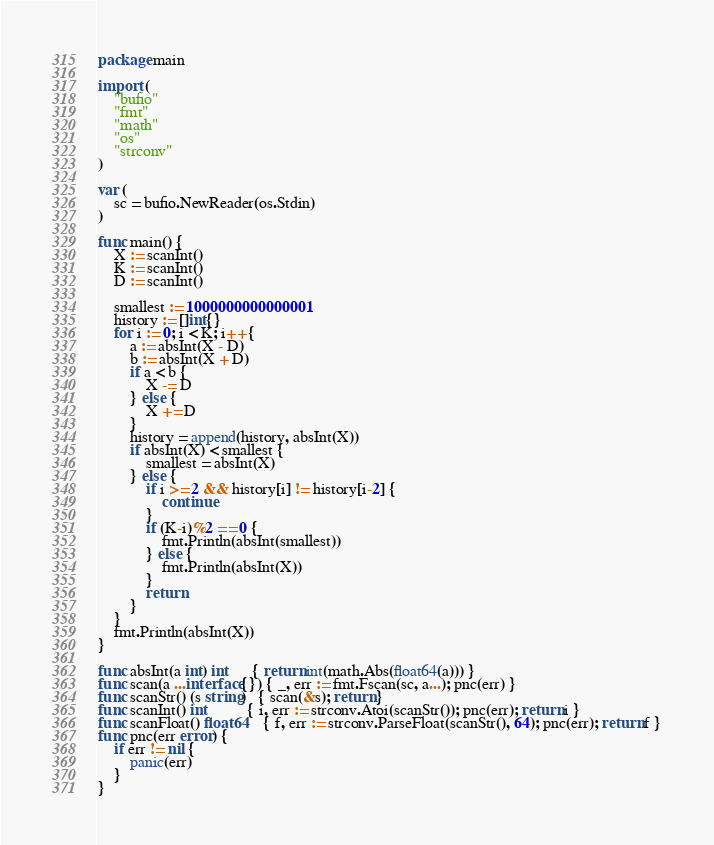Convert code to text. <code><loc_0><loc_0><loc_500><loc_500><_Go_>package main

import (
	"bufio"
	"fmt"
	"math"
	"os"
	"strconv"
)

var (
	sc = bufio.NewReader(os.Stdin)
)

func main() {
	X := scanInt()
	K := scanInt()
	D := scanInt()

	smallest := 1000000000000001
	history := []int{}
	for i := 0; i < K; i++ {
		a := absInt(X - D)
		b := absInt(X + D)
		if a < b {
			X -= D
		} else {
			X += D
		}
		history = append(history, absInt(X))
		if absInt(X) < smallest {
			smallest = absInt(X)
		} else {
			if i >= 2 && history[i] != history[i-2] {
				continue
			}
			if (K-i)%2 == 0 {
				fmt.Println(absInt(smallest))
			} else {
				fmt.Println(absInt(X))
			}
			return
		}
	}
	fmt.Println(absInt(X))
}

func absInt(a int) int      { return int(math.Abs(float64(a))) }
func scan(a ...interface{}) { _, err := fmt.Fscan(sc, a...); pnc(err) }
func scanStr() (s string)   { scan(&s); return }
func scanInt() int          { i, err := strconv.Atoi(scanStr()); pnc(err); return i }
func scanFloat() float64    { f, err := strconv.ParseFloat(scanStr(), 64); pnc(err); return f }
func pnc(err error) {
	if err != nil {
		panic(err)
	}
}
</code> 